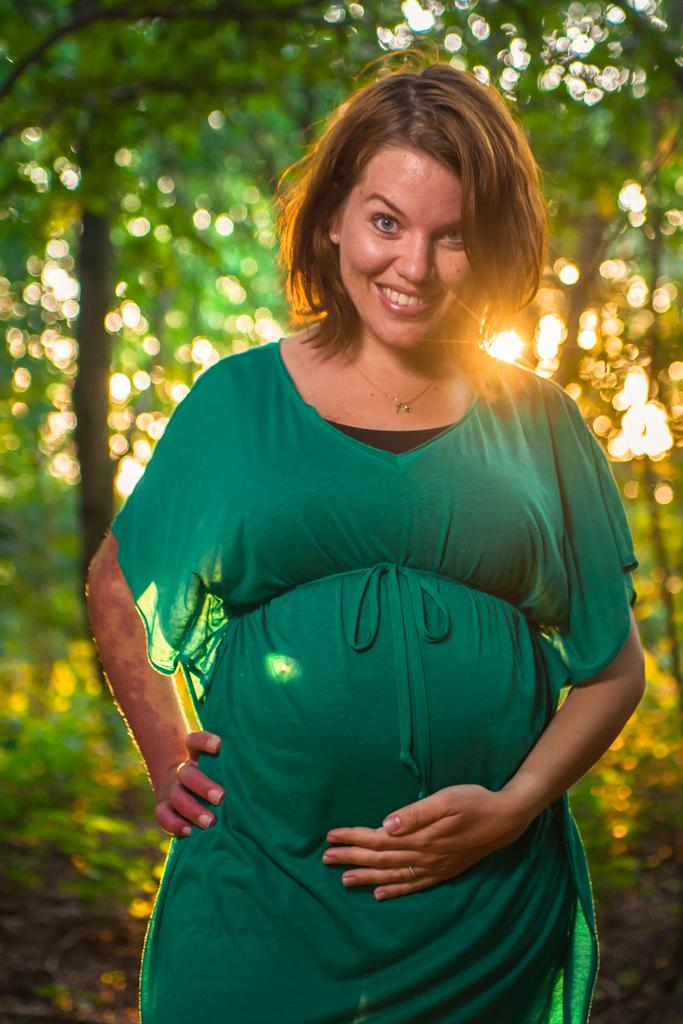Who is the main subject in the image? There is a woman in the image. What is the woman doing in the image? The woman is smiling and posing for a photo. What can be seen in the background of the image? There are trees and sunlight visible in the background of the image. What type of question is the woman holding in the image? There is no question visible in the image; the woman is holding a smile and posing for a photo. 